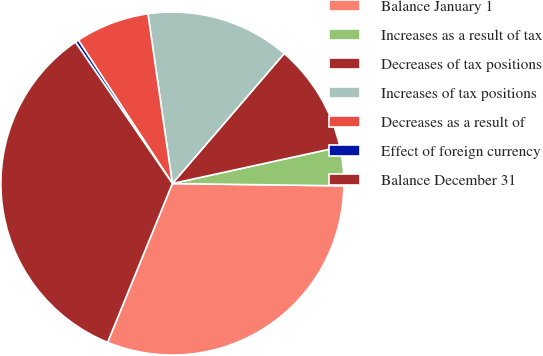Convert chart to OTSL. <chart><loc_0><loc_0><loc_500><loc_500><pie_chart><fcel>Balance January 1<fcel>Increases as a result of tax<fcel>Decreases of tax positions<fcel>Increases of tax positions<fcel>Decreases as a result of<fcel>Effect of foreign currency<fcel>Balance December 31<nl><fcel>30.95%<fcel>3.64%<fcel>10.27%<fcel>13.58%<fcel>6.96%<fcel>0.33%<fcel>34.27%<nl></chart> 